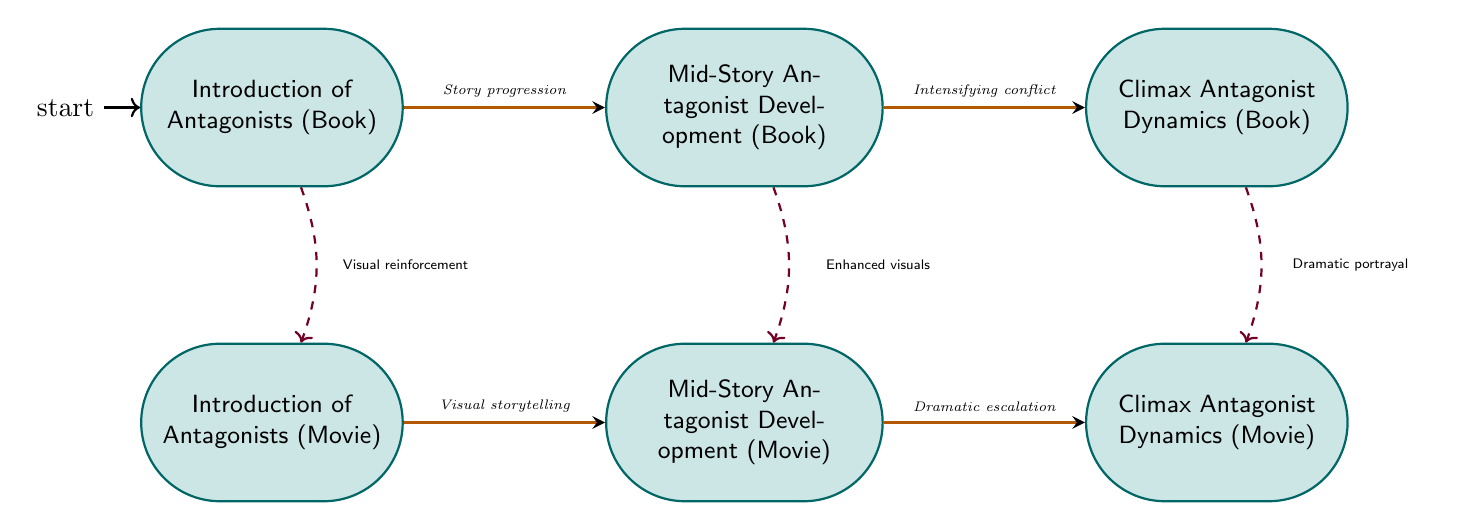What are the two main types of states presented in the diagram? The states in the diagram are categorized into two main types: those related to the book and those related to the movie. Each category has its own progression from introduction to climax of the antagonists.
Answer: Book and Movie How many states are there in total in the diagram? The diagram contains six states: three for the book and three for the movie. When counted together, they total six states.
Answer: Six What transitional relationship exists between the initial and mid-story states in the book? In the diagram, there is a directed edge labeled "Story progression" that shows the transition from the 'Introduction of Antagonists (Book)' state to the 'Mid-Story Antagonist Development (Book)' state. This indicates that the development progresses from initial to mid-story antagonists.
Answer: Story progression Which state represents the climax of antagonist dynamics in the movie? The state labeled 'Climax Antagonist Dynamics (Movie)' explicitly represents the climax of antagonist dynamics in the movie, as categorized in the diagram.
Answer: Climax Antagonist Dynamics (Movie) What is the relationship between the mid-story antagonists in both the book and the movie according to the diagram? The diagram shows a transition from the 'Mid-Story Antagonist Development (Book)' to the 'Mid-Story Antagonist Development (Movie)' with a dashed line indicating a similar progress in both adaptations, while the annotations suggest "Enhanced visuals" for the movie, highlighting additional elements of storytelling.
Answer: Enhanced visuals What is noted about President Snow's portrayal in both versions? The diagram indicates that President Snow has a frightening presence in both the book and the movie. The transition arrows signify visual elements that reinforce the sinister demeanor, with greater screen time emphasis in the movie.
Answer: Sinister demeanor How does the climax portrayal of Cato differ between the book and movie? In the diagram, the portrayal of Cato at the climax demonstrates a more pronounced dramatic confrontation in the movie, contrasted with the narrative emphasis on mind games in the book. These differences are highlighted by the transition annotations.
Answer: Dramatic confrontation What type of transitions are noted for the movie's antagonist development? The transitions noted from the movie's introduction to mid-story and from mid-story to climax are described with phrases such as "Visual storytelling" and "Dramatic escalation," indicating an emphasis on visual dynamics and heightened drama.
Answer: Visual storytelling and Dramatic escalation 